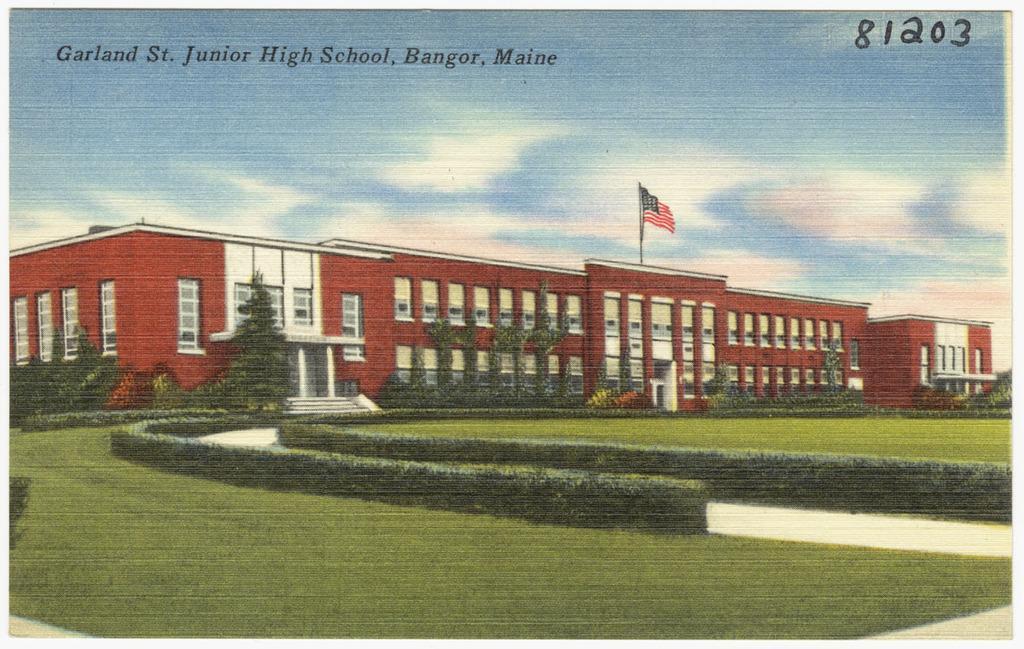Describe this image in one or two sentences. This image is a poster. In this image we can see a building with flag. There are plants. At the bottom of the image there is grass. At the top of the image there is sky with some text. 